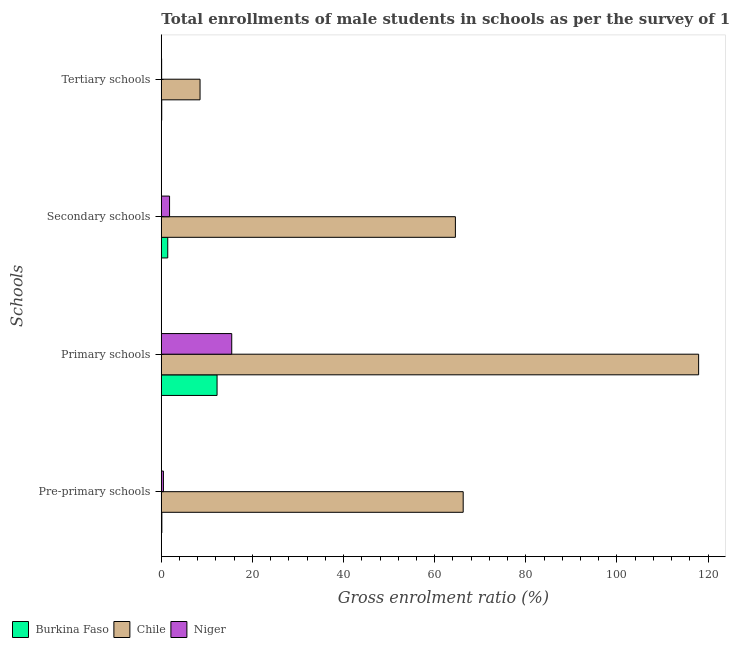How many groups of bars are there?
Your response must be concise. 4. Are the number of bars per tick equal to the number of legend labels?
Your response must be concise. Yes. Are the number of bars on each tick of the Y-axis equal?
Give a very brief answer. Yes. How many bars are there on the 1st tick from the top?
Ensure brevity in your answer.  3. How many bars are there on the 2nd tick from the bottom?
Provide a short and direct response. 3. What is the label of the 2nd group of bars from the top?
Keep it short and to the point. Secondary schools. What is the gross enrolment ratio(male) in secondary schools in Niger?
Provide a succinct answer. 1.81. Across all countries, what is the maximum gross enrolment ratio(male) in pre-primary schools?
Provide a succinct answer. 66.26. Across all countries, what is the minimum gross enrolment ratio(male) in secondary schools?
Your response must be concise. 1.41. In which country was the gross enrolment ratio(male) in tertiary schools minimum?
Your answer should be very brief. Niger. What is the total gross enrolment ratio(male) in tertiary schools in the graph?
Your answer should be very brief. 8.66. What is the difference between the gross enrolment ratio(male) in pre-primary schools in Niger and that in Burkina Faso?
Your answer should be compact. 0.34. What is the difference between the gross enrolment ratio(male) in pre-primary schools in Niger and the gross enrolment ratio(male) in secondary schools in Burkina Faso?
Provide a short and direct response. -0.95. What is the average gross enrolment ratio(male) in secondary schools per country?
Provide a short and direct response. 22.59. What is the difference between the gross enrolment ratio(male) in secondary schools and gross enrolment ratio(male) in tertiary schools in Burkina Faso?
Offer a terse response. 1.32. In how many countries, is the gross enrolment ratio(male) in pre-primary schools greater than 4 %?
Keep it short and to the point. 1. What is the ratio of the gross enrolment ratio(male) in primary schools in Chile to that in Niger?
Make the answer very short. 7.63. Is the gross enrolment ratio(male) in pre-primary schools in Chile less than that in Niger?
Your answer should be compact. No. What is the difference between the highest and the second highest gross enrolment ratio(male) in pre-primary schools?
Your answer should be compact. 65.8. What is the difference between the highest and the lowest gross enrolment ratio(male) in tertiary schools?
Give a very brief answer. 8.43. Is it the case that in every country, the sum of the gross enrolment ratio(male) in secondary schools and gross enrolment ratio(male) in tertiary schools is greater than the sum of gross enrolment ratio(male) in primary schools and gross enrolment ratio(male) in pre-primary schools?
Provide a short and direct response. No. What does the 1st bar from the bottom in Primary schools represents?
Your response must be concise. Burkina Faso. Are the values on the major ticks of X-axis written in scientific E-notation?
Your response must be concise. No. Does the graph contain any zero values?
Make the answer very short. No. Does the graph contain grids?
Offer a very short reply. No. Where does the legend appear in the graph?
Provide a short and direct response. Bottom left. What is the title of the graph?
Keep it short and to the point. Total enrollments of male students in schools as per the survey of 1979 conducted in different countries. Does "Turkmenistan" appear as one of the legend labels in the graph?
Provide a short and direct response. No. What is the label or title of the Y-axis?
Provide a succinct answer. Schools. What is the Gross enrolment ratio (%) in Burkina Faso in Pre-primary schools?
Provide a short and direct response. 0.12. What is the Gross enrolment ratio (%) in Chile in Pre-primary schools?
Your response must be concise. 66.26. What is the Gross enrolment ratio (%) of Niger in Pre-primary schools?
Your response must be concise. 0.46. What is the Gross enrolment ratio (%) of Burkina Faso in Primary schools?
Provide a short and direct response. 12.24. What is the Gross enrolment ratio (%) of Chile in Primary schools?
Keep it short and to the point. 117.93. What is the Gross enrolment ratio (%) in Niger in Primary schools?
Offer a terse response. 15.46. What is the Gross enrolment ratio (%) in Burkina Faso in Secondary schools?
Offer a terse response. 1.41. What is the Gross enrolment ratio (%) of Chile in Secondary schools?
Provide a succinct answer. 64.55. What is the Gross enrolment ratio (%) of Niger in Secondary schools?
Make the answer very short. 1.81. What is the Gross enrolment ratio (%) of Burkina Faso in Tertiary schools?
Your answer should be very brief. 0.09. What is the Gross enrolment ratio (%) in Chile in Tertiary schools?
Give a very brief answer. 8.5. What is the Gross enrolment ratio (%) in Niger in Tertiary schools?
Offer a terse response. 0.07. Across all Schools, what is the maximum Gross enrolment ratio (%) in Burkina Faso?
Keep it short and to the point. 12.24. Across all Schools, what is the maximum Gross enrolment ratio (%) of Chile?
Ensure brevity in your answer.  117.93. Across all Schools, what is the maximum Gross enrolment ratio (%) in Niger?
Keep it short and to the point. 15.46. Across all Schools, what is the minimum Gross enrolment ratio (%) in Burkina Faso?
Your answer should be very brief. 0.09. Across all Schools, what is the minimum Gross enrolment ratio (%) of Chile?
Your answer should be very brief. 8.5. Across all Schools, what is the minimum Gross enrolment ratio (%) of Niger?
Make the answer very short. 0.07. What is the total Gross enrolment ratio (%) of Burkina Faso in the graph?
Provide a short and direct response. 13.86. What is the total Gross enrolment ratio (%) in Chile in the graph?
Your response must be concise. 257.24. What is the total Gross enrolment ratio (%) of Niger in the graph?
Your response must be concise. 17.8. What is the difference between the Gross enrolment ratio (%) of Burkina Faso in Pre-primary schools and that in Primary schools?
Offer a terse response. -12.12. What is the difference between the Gross enrolment ratio (%) of Chile in Pre-primary schools and that in Primary schools?
Provide a short and direct response. -51.68. What is the difference between the Gross enrolment ratio (%) in Niger in Pre-primary schools and that in Primary schools?
Keep it short and to the point. -15. What is the difference between the Gross enrolment ratio (%) in Burkina Faso in Pre-primary schools and that in Secondary schools?
Make the answer very short. -1.29. What is the difference between the Gross enrolment ratio (%) of Chile in Pre-primary schools and that in Secondary schools?
Make the answer very short. 1.71. What is the difference between the Gross enrolment ratio (%) of Niger in Pre-primary schools and that in Secondary schools?
Your response must be concise. -1.35. What is the difference between the Gross enrolment ratio (%) in Burkina Faso in Pre-primary schools and that in Tertiary schools?
Your answer should be very brief. 0.03. What is the difference between the Gross enrolment ratio (%) in Chile in Pre-primary schools and that in Tertiary schools?
Your answer should be very brief. 57.76. What is the difference between the Gross enrolment ratio (%) of Niger in Pre-primary schools and that in Tertiary schools?
Ensure brevity in your answer.  0.39. What is the difference between the Gross enrolment ratio (%) of Burkina Faso in Primary schools and that in Secondary schools?
Make the answer very short. 10.82. What is the difference between the Gross enrolment ratio (%) in Chile in Primary schools and that in Secondary schools?
Offer a terse response. 53.39. What is the difference between the Gross enrolment ratio (%) of Niger in Primary schools and that in Secondary schools?
Your response must be concise. 13.65. What is the difference between the Gross enrolment ratio (%) in Burkina Faso in Primary schools and that in Tertiary schools?
Give a very brief answer. 12.14. What is the difference between the Gross enrolment ratio (%) in Chile in Primary schools and that in Tertiary schools?
Your answer should be very brief. 109.43. What is the difference between the Gross enrolment ratio (%) in Niger in Primary schools and that in Tertiary schools?
Offer a very short reply. 15.39. What is the difference between the Gross enrolment ratio (%) in Burkina Faso in Secondary schools and that in Tertiary schools?
Your response must be concise. 1.32. What is the difference between the Gross enrolment ratio (%) of Chile in Secondary schools and that in Tertiary schools?
Offer a terse response. 56.04. What is the difference between the Gross enrolment ratio (%) in Niger in Secondary schools and that in Tertiary schools?
Keep it short and to the point. 1.74. What is the difference between the Gross enrolment ratio (%) in Burkina Faso in Pre-primary schools and the Gross enrolment ratio (%) in Chile in Primary schools?
Your response must be concise. -117.82. What is the difference between the Gross enrolment ratio (%) of Burkina Faso in Pre-primary schools and the Gross enrolment ratio (%) of Niger in Primary schools?
Your answer should be compact. -15.34. What is the difference between the Gross enrolment ratio (%) in Chile in Pre-primary schools and the Gross enrolment ratio (%) in Niger in Primary schools?
Provide a short and direct response. 50.8. What is the difference between the Gross enrolment ratio (%) of Burkina Faso in Pre-primary schools and the Gross enrolment ratio (%) of Chile in Secondary schools?
Your answer should be very brief. -64.43. What is the difference between the Gross enrolment ratio (%) in Burkina Faso in Pre-primary schools and the Gross enrolment ratio (%) in Niger in Secondary schools?
Offer a terse response. -1.69. What is the difference between the Gross enrolment ratio (%) in Chile in Pre-primary schools and the Gross enrolment ratio (%) in Niger in Secondary schools?
Offer a very short reply. 64.45. What is the difference between the Gross enrolment ratio (%) in Burkina Faso in Pre-primary schools and the Gross enrolment ratio (%) in Chile in Tertiary schools?
Your answer should be compact. -8.38. What is the difference between the Gross enrolment ratio (%) of Burkina Faso in Pre-primary schools and the Gross enrolment ratio (%) of Niger in Tertiary schools?
Keep it short and to the point. 0.05. What is the difference between the Gross enrolment ratio (%) of Chile in Pre-primary schools and the Gross enrolment ratio (%) of Niger in Tertiary schools?
Give a very brief answer. 66.19. What is the difference between the Gross enrolment ratio (%) of Burkina Faso in Primary schools and the Gross enrolment ratio (%) of Chile in Secondary schools?
Your answer should be compact. -52.31. What is the difference between the Gross enrolment ratio (%) in Burkina Faso in Primary schools and the Gross enrolment ratio (%) in Niger in Secondary schools?
Your response must be concise. 10.43. What is the difference between the Gross enrolment ratio (%) in Chile in Primary schools and the Gross enrolment ratio (%) in Niger in Secondary schools?
Make the answer very short. 116.13. What is the difference between the Gross enrolment ratio (%) of Burkina Faso in Primary schools and the Gross enrolment ratio (%) of Chile in Tertiary schools?
Your answer should be very brief. 3.73. What is the difference between the Gross enrolment ratio (%) in Burkina Faso in Primary schools and the Gross enrolment ratio (%) in Niger in Tertiary schools?
Your answer should be compact. 12.17. What is the difference between the Gross enrolment ratio (%) in Chile in Primary schools and the Gross enrolment ratio (%) in Niger in Tertiary schools?
Your answer should be very brief. 117.86. What is the difference between the Gross enrolment ratio (%) of Burkina Faso in Secondary schools and the Gross enrolment ratio (%) of Chile in Tertiary schools?
Give a very brief answer. -7.09. What is the difference between the Gross enrolment ratio (%) in Burkina Faso in Secondary schools and the Gross enrolment ratio (%) in Niger in Tertiary schools?
Your response must be concise. 1.34. What is the difference between the Gross enrolment ratio (%) in Chile in Secondary schools and the Gross enrolment ratio (%) in Niger in Tertiary schools?
Provide a short and direct response. 64.48. What is the average Gross enrolment ratio (%) in Burkina Faso per Schools?
Keep it short and to the point. 3.46. What is the average Gross enrolment ratio (%) in Chile per Schools?
Provide a short and direct response. 64.31. What is the average Gross enrolment ratio (%) of Niger per Schools?
Ensure brevity in your answer.  4.45. What is the difference between the Gross enrolment ratio (%) of Burkina Faso and Gross enrolment ratio (%) of Chile in Pre-primary schools?
Offer a very short reply. -66.14. What is the difference between the Gross enrolment ratio (%) in Burkina Faso and Gross enrolment ratio (%) in Niger in Pre-primary schools?
Your answer should be very brief. -0.34. What is the difference between the Gross enrolment ratio (%) of Chile and Gross enrolment ratio (%) of Niger in Pre-primary schools?
Offer a terse response. 65.8. What is the difference between the Gross enrolment ratio (%) in Burkina Faso and Gross enrolment ratio (%) in Chile in Primary schools?
Keep it short and to the point. -105.7. What is the difference between the Gross enrolment ratio (%) in Burkina Faso and Gross enrolment ratio (%) in Niger in Primary schools?
Provide a succinct answer. -3.22. What is the difference between the Gross enrolment ratio (%) of Chile and Gross enrolment ratio (%) of Niger in Primary schools?
Provide a short and direct response. 102.48. What is the difference between the Gross enrolment ratio (%) in Burkina Faso and Gross enrolment ratio (%) in Chile in Secondary schools?
Give a very brief answer. -63.13. What is the difference between the Gross enrolment ratio (%) in Burkina Faso and Gross enrolment ratio (%) in Niger in Secondary schools?
Provide a short and direct response. -0.4. What is the difference between the Gross enrolment ratio (%) of Chile and Gross enrolment ratio (%) of Niger in Secondary schools?
Your answer should be compact. 62.74. What is the difference between the Gross enrolment ratio (%) of Burkina Faso and Gross enrolment ratio (%) of Chile in Tertiary schools?
Ensure brevity in your answer.  -8.41. What is the difference between the Gross enrolment ratio (%) in Burkina Faso and Gross enrolment ratio (%) in Niger in Tertiary schools?
Provide a short and direct response. 0.02. What is the difference between the Gross enrolment ratio (%) of Chile and Gross enrolment ratio (%) of Niger in Tertiary schools?
Make the answer very short. 8.43. What is the ratio of the Gross enrolment ratio (%) in Burkina Faso in Pre-primary schools to that in Primary schools?
Your answer should be very brief. 0.01. What is the ratio of the Gross enrolment ratio (%) in Chile in Pre-primary schools to that in Primary schools?
Give a very brief answer. 0.56. What is the ratio of the Gross enrolment ratio (%) in Niger in Pre-primary schools to that in Primary schools?
Provide a short and direct response. 0.03. What is the ratio of the Gross enrolment ratio (%) of Burkina Faso in Pre-primary schools to that in Secondary schools?
Give a very brief answer. 0.08. What is the ratio of the Gross enrolment ratio (%) of Chile in Pre-primary schools to that in Secondary schools?
Offer a terse response. 1.03. What is the ratio of the Gross enrolment ratio (%) of Niger in Pre-primary schools to that in Secondary schools?
Ensure brevity in your answer.  0.25. What is the ratio of the Gross enrolment ratio (%) of Burkina Faso in Pre-primary schools to that in Tertiary schools?
Offer a terse response. 1.29. What is the ratio of the Gross enrolment ratio (%) of Chile in Pre-primary schools to that in Tertiary schools?
Your answer should be very brief. 7.79. What is the ratio of the Gross enrolment ratio (%) of Niger in Pre-primary schools to that in Tertiary schools?
Keep it short and to the point. 6.59. What is the ratio of the Gross enrolment ratio (%) in Burkina Faso in Primary schools to that in Secondary schools?
Give a very brief answer. 8.67. What is the ratio of the Gross enrolment ratio (%) in Chile in Primary schools to that in Secondary schools?
Your response must be concise. 1.83. What is the ratio of the Gross enrolment ratio (%) in Niger in Primary schools to that in Secondary schools?
Provide a short and direct response. 8.55. What is the ratio of the Gross enrolment ratio (%) in Burkina Faso in Primary schools to that in Tertiary schools?
Your response must be concise. 133.53. What is the ratio of the Gross enrolment ratio (%) in Chile in Primary schools to that in Tertiary schools?
Your answer should be very brief. 13.87. What is the ratio of the Gross enrolment ratio (%) in Niger in Primary schools to that in Tertiary schools?
Your answer should be compact. 221.01. What is the ratio of the Gross enrolment ratio (%) of Burkina Faso in Secondary schools to that in Tertiary schools?
Your answer should be very brief. 15.4. What is the ratio of the Gross enrolment ratio (%) in Chile in Secondary schools to that in Tertiary schools?
Provide a short and direct response. 7.59. What is the ratio of the Gross enrolment ratio (%) in Niger in Secondary schools to that in Tertiary schools?
Offer a very short reply. 25.86. What is the difference between the highest and the second highest Gross enrolment ratio (%) in Burkina Faso?
Offer a very short reply. 10.82. What is the difference between the highest and the second highest Gross enrolment ratio (%) of Chile?
Your answer should be very brief. 51.68. What is the difference between the highest and the second highest Gross enrolment ratio (%) of Niger?
Provide a short and direct response. 13.65. What is the difference between the highest and the lowest Gross enrolment ratio (%) in Burkina Faso?
Offer a terse response. 12.14. What is the difference between the highest and the lowest Gross enrolment ratio (%) of Chile?
Provide a short and direct response. 109.43. What is the difference between the highest and the lowest Gross enrolment ratio (%) in Niger?
Ensure brevity in your answer.  15.39. 